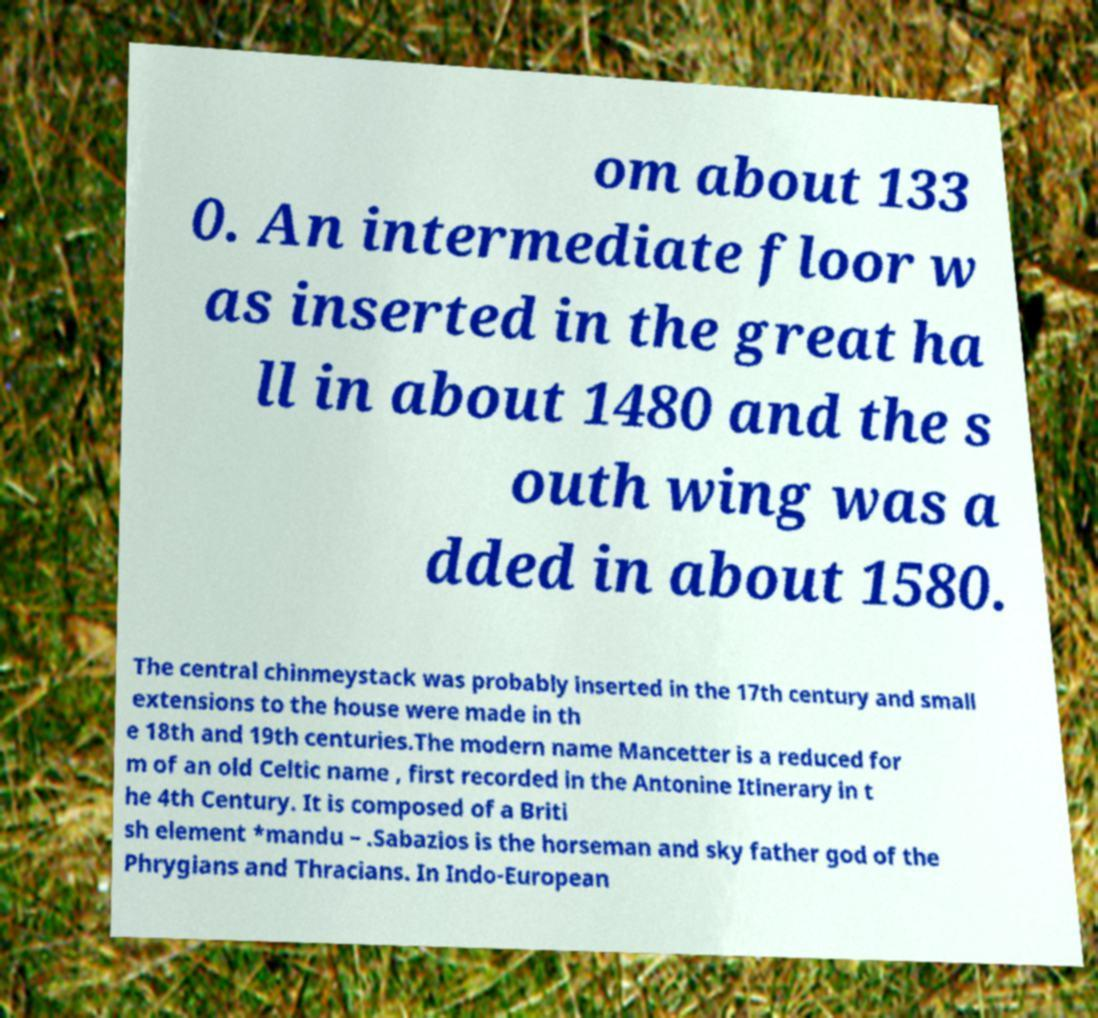Could you extract and type out the text from this image? om about 133 0. An intermediate floor w as inserted in the great ha ll in about 1480 and the s outh wing was a dded in about 1580. The central chinmeystack was probably inserted in the 17th century and small extensions to the house were made in th e 18th and 19th centuries.The modern name Mancetter is a reduced for m of an old Celtic name , first recorded in the Antonine Itinerary in t he 4th Century. It is composed of a Briti sh element *mandu – .Sabazios is the horseman and sky father god of the Phrygians and Thracians. In Indo-European 